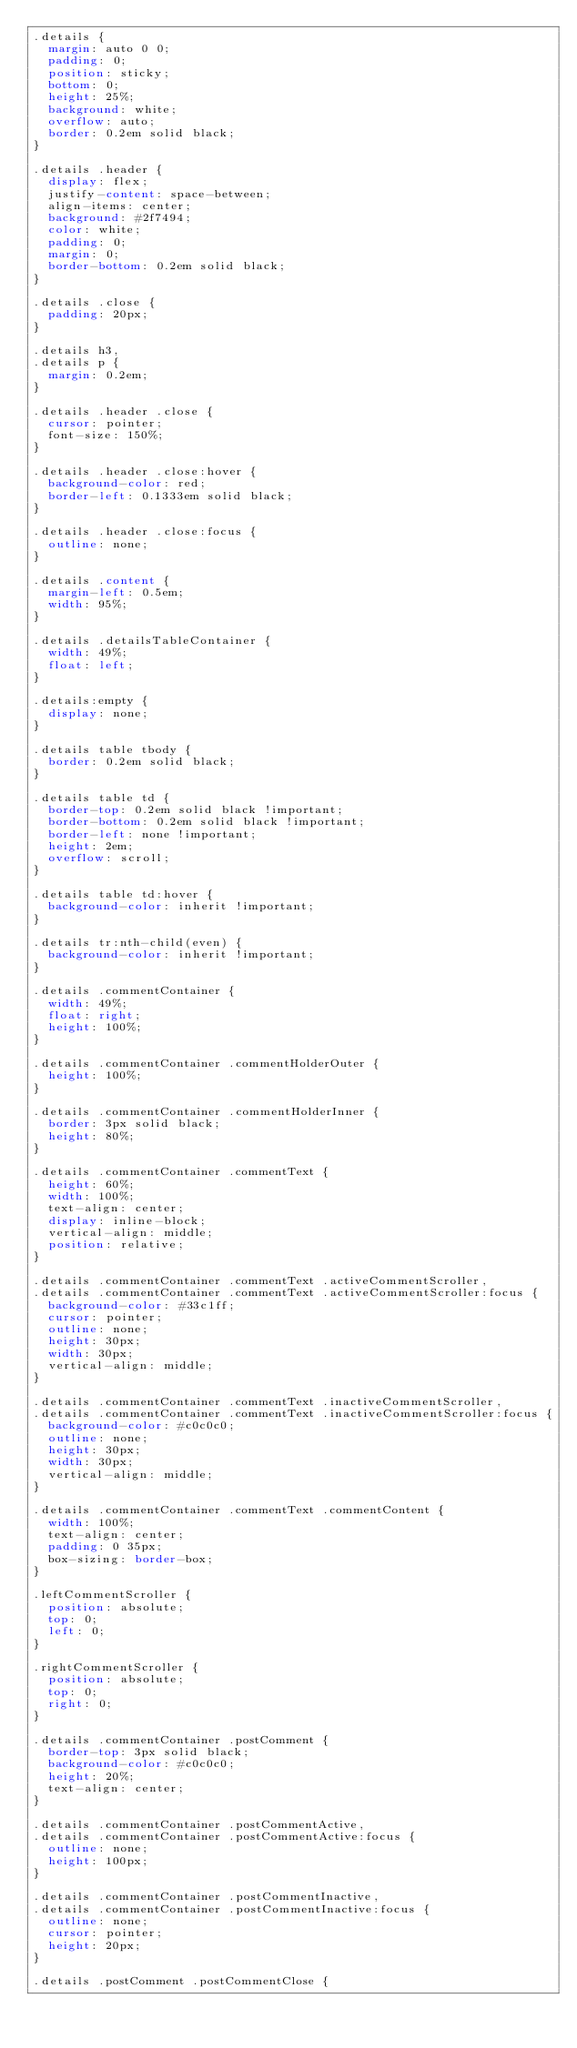Convert code to text. <code><loc_0><loc_0><loc_500><loc_500><_CSS_>.details {
  margin: auto 0 0;
  padding: 0;
  position: sticky;
  bottom: 0;
  height: 25%;
  background: white;
  overflow: auto;
  border: 0.2em solid black;
}

.details .header {
  display: flex;
  justify-content: space-between;
  align-items: center;
  background: #2f7494;
  color: white;
  padding: 0;
  margin: 0;
  border-bottom: 0.2em solid black;
}

.details .close {
  padding: 20px;
}

.details h3,
.details p {
  margin: 0.2em;
}

.details .header .close {
  cursor: pointer;
  font-size: 150%;
}

.details .header .close:hover {
  background-color: red;
  border-left: 0.1333em solid black;
}

.details .header .close:focus {
  outline: none;
}

.details .content {
  margin-left: 0.5em;
  width: 95%;
}

.details .detailsTableContainer {
  width: 49%;
  float: left;
}

.details:empty {
  display: none;
}

.details table tbody {
  border: 0.2em solid black;
}

.details table td {
  border-top: 0.2em solid black !important;
  border-bottom: 0.2em solid black !important;
  border-left: none !important;
  height: 2em;
  overflow: scroll;
}

.details table td:hover {
  background-color: inherit !important;
}

.details tr:nth-child(even) {
  background-color: inherit !important;
}

.details .commentContainer {
  width: 49%;
  float: right;
  height: 100%;
}

.details .commentContainer .commentHolderOuter {
  height: 100%;
}

.details .commentContainer .commentHolderInner {
  border: 3px solid black;
  height: 80%;
}

.details .commentContainer .commentText {
  height: 60%;
  width: 100%;
  text-align: center;
  display: inline-block;
  vertical-align: middle;
  position: relative;
}

.details .commentContainer .commentText .activeCommentScroller,
.details .commentContainer .commentText .activeCommentScroller:focus {
  background-color: #33c1ff;
  cursor: pointer;
  outline: none;
  height: 30px;
  width: 30px;
  vertical-align: middle;
}

.details .commentContainer .commentText .inactiveCommentScroller,
.details .commentContainer .commentText .inactiveCommentScroller:focus {
  background-color: #c0c0c0;
  outline: none;
  height: 30px;
  width: 30px;
  vertical-align: middle;
}

.details .commentContainer .commentText .commentContent {
  width: 100%;
  text-align: center;
  padding: 0 35px;
  box-sizing: border-box;
}

.leftCommentScroller {
  position: absolute;
  top: 0;
  left: 0;
}

.rightCommentScroller {
  position: absolute;
  top: 0;
  right: 0;
}

.details .commentContainer .postComment {
  border-top: 3px solid black;
  background-color: #c0c0c0;
  height: 20%;
  text-align: center;
}

.details .commentContainer .postCommentActive,
.details .commentContainer .postCommentActive:focus {
  outline: none;
  height: 100px;
}

.details .commentContainer .postCommentInactive,
.details .commentContainer .postCommentInactive:focus {
  outline: none;
  cursor: pointer;
  height: 20px;
}

.details .postComment .postCommentClose {</code> 